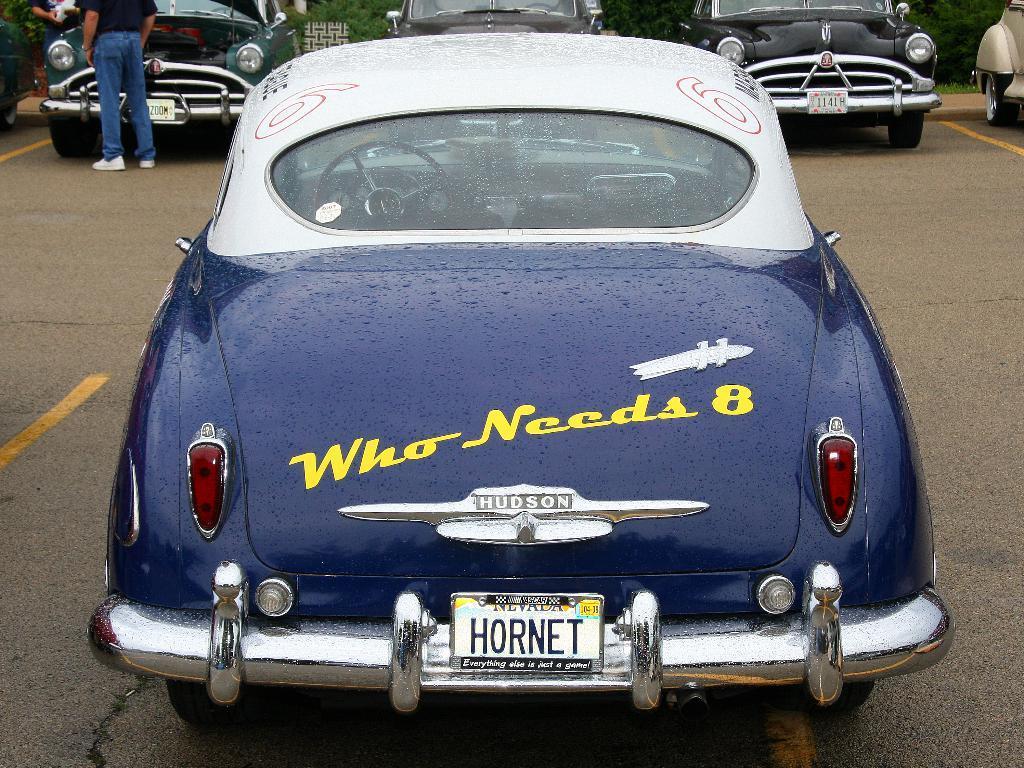In one or two sentences, can you explain what this image depicts? In this picture we can see a vehicle on the ground and in the background we can see people, vehicles and trees. 